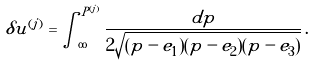<formula> <loc_0><loc_0><loc_500><loc_500>\delta u ^ { ( j ) } = \int _ { \infty } ^ { P ^ { ( j ) } } \frac { d p } { 2 \sqrt { ( p - e _ { 1 } ) ( p - e _ { 2 } ) ( p - e _ { 3 } ) } } \, .</formula> 